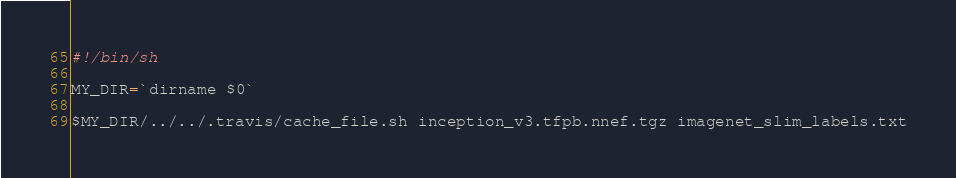<code> <loc_0><loc_0><loc_500><loc_500><_Bash_>#!/bin/sh

MY_DIR=`dirname $0`

$MY_DIR/../../.travis/cache_file.sh inception_v3.tfpb.nnef.tgz imagenet_slim_labels.txt
</code> 